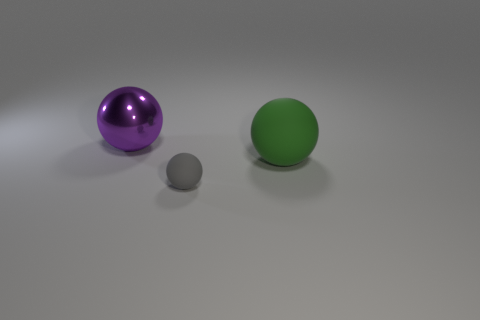Subtract all small matte balls. How many balls are left? 2 Add 3 brown rubber cubes. How many objects exist? 6 Add 1 tiny blue cylinders. How many tiny blue cylinders exist? 1 Subtract 0 yellow cylinders. How many objects are left? 3 Subtract all gray balls. Subtract all yellow cubes. How many balls are left? 2 Subtract all big green rubber things. Subtract all purple shiny things. How many objects are left? 1 Add 1 gray things. How many gray things are left? 2 